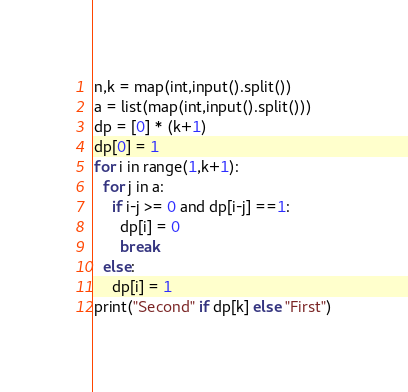<code> <loc_0><loc_0><loc_500><loc_500><_Python_>n,k = map(int,input().split())
a = list(map(int,input().split()))
dp = [0] * (k+1)
dp[0] = 1
for i in range(1,k+1):
  for j in a:
    if i-j >= 0 and dp[i-j] ==1:
      dp[i] = 0
      break
  else:
    dp[i] = 1
print("Second" if dp[k] else "First")</code> 